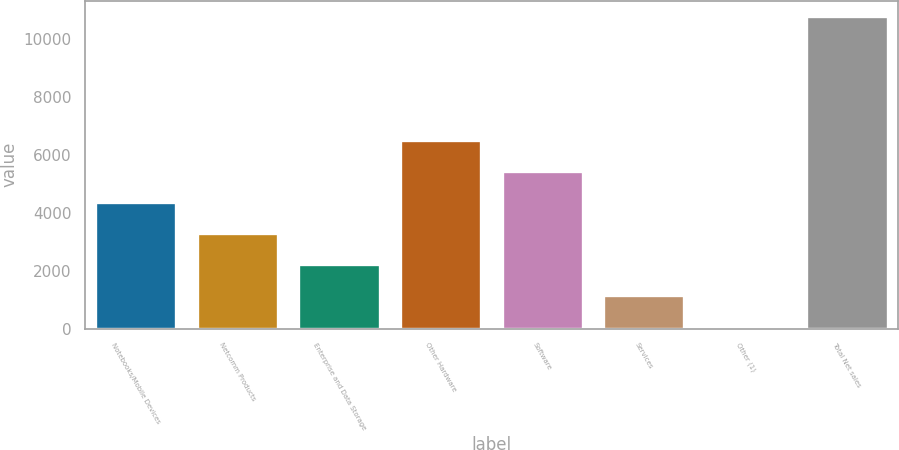<chart> <loc_0><loc_0><loc_500><loc_500><bar_chart><fcel>Notebooks/Mobile Devices<fcel>Netcomm Products<fcel>Enterprise and Data Storage<fcel>Other Hardware<fcel>Software<fcel>Services<fcel>Other (1)<fcel>Total Net sales<nl><fcel>4361.98<fcel>3294.21<fcel>2226.44<fcel>6497.52<fcel>5429.75<fcel>1158.67<fcel>90.9<fcel>10768.6<nl></chart> 